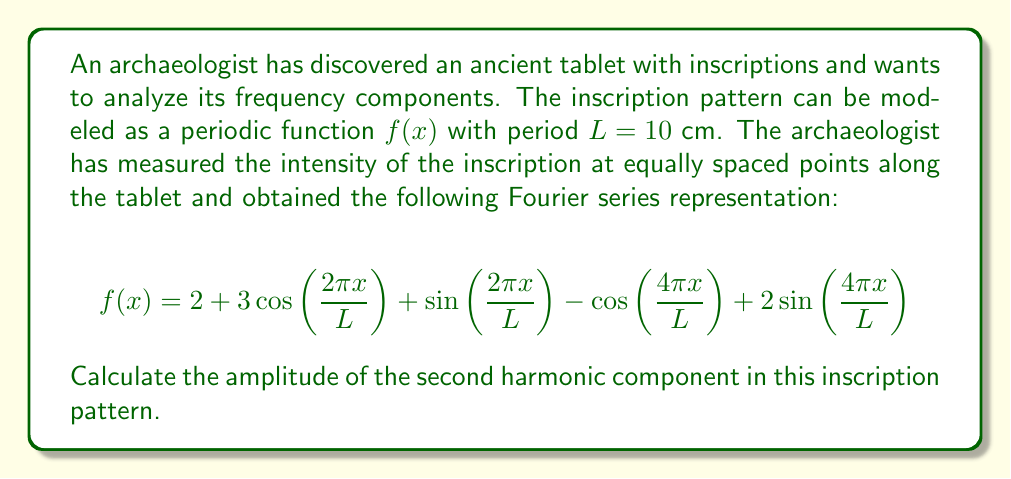Can you answer this question? To solve this problem, we need to understand the Fourier series representation and identify the components of the second harmonic. Let's break it down step-by-step:

1) The general form of a Fourier series is:

   $$f(x) = a_0 + \sum_{n=1}^{\infty} \left[a_n\cos\left(\frac{2\pi nx}{L}\right) + b_n\sin\left(\frac{2\pi nx}{L}\right)\right]$$

2) In our case, we have:
   - $a_0 = 2$ (the constant term)
   - $a_1 = 3$ and $b_1 = 1$ (coefficients of the first harmonic)
   - $a_2 = -1$ and $b_2 = 2$ (coefficients of the second harmonic)

3) The second harmonic components are:

   $$-\cos\left(\frac{4\pi x}{L}\right) + 2\sin\left(\frac{4\pi x}{L}\right)$$

4) To find the amplitude of the second harmonic, we need to calculate:

   $$A_2 = \sqrt{a_2^2 + b_2^2}$$

5) Substituting the values:

   $$A_2 = \sqrt{(-1)^2 + 2^2} = \sqrt{1 + 4} = \sqrt{5}$$

Therefore, the amplitude of the second harmonic component is $\sqrt{5}$.
Answer: $\sqrt{5}$ 